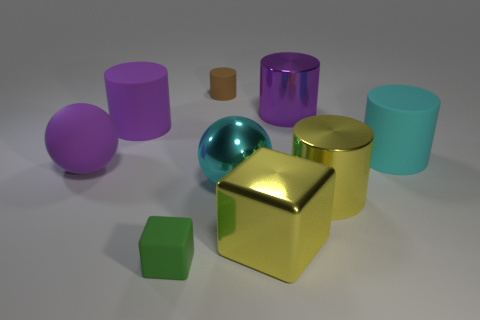There is a big purple cylinder that is on the left side of the large purple shiny cylinder; what number of large purple things are in front of it?
Make the answer very short. 1. The big cyan rubber thing has what shape?
Your answer should be very brief. Cylinder. What shape is the big cyan thing that is the same material as the large purple sphere?
Provide a short and direct response. Cylinder. There is a purple rubber thing in front of the big cyan cylinder; is its shape the same as the green matte object?
Your answer should be compact. No. What shape is the shiny thing that is behind the rubber ball?
Offer a very short reply. Cylinder. There is a shiny thing that is the same color as the large cube; what shape is it?
Provide a succinct answer. Cylinder. How many cyan metallic objects have the same size as the purple ball?
Ensure brevity in your answer.  1. What is the color of the shiny sphere?
Make the answer very short. Cyan. There is a large rubber sphere; is its color the same as the large rubber cylinder that is to the left of the big yellow block?
Keep it short and to the point. Yes. What is the size of the brown object that is made of the same material as the small green object?
Provide a short and direct response. Small. 